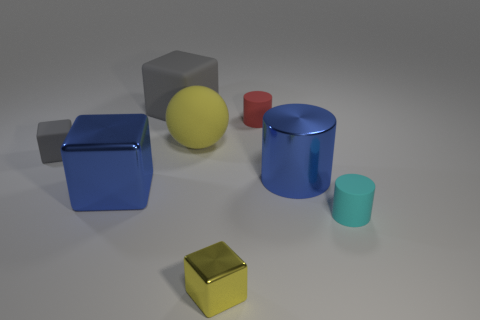Subtract all large cylinders. How many cylinders are left? 2 Subtract all yellow blocks. How many blocks are left? 3 Subtract all spheres. How many objects are left? 7 Subtract 1 balls. How many balls are left? 0 Add 1 tiny cyan rubber things. How many objects exist? 9 Subtract all cyan spheres. How many brown cylinders are left? 0 Subtract all large metallic blocks. Subtract all tiny cyan objects. How many objects are left? 6 Add 8 large gray things. How many large gray things are left? 9 Add 6 small rubber things. How many small rubber things exist? 9 Subtract 0 brown cylinders. How many objects are left? 8 